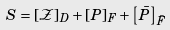Convert formula to latex. <formula><loc_0><loc_0><loc_500><loc_500>S & = \left [ \mathcal { Z } \right ] _ { D } + \left [ P \right ] _ { F } + \left [ \bar { P } \right ] _ { \bar { F } }</formula> 